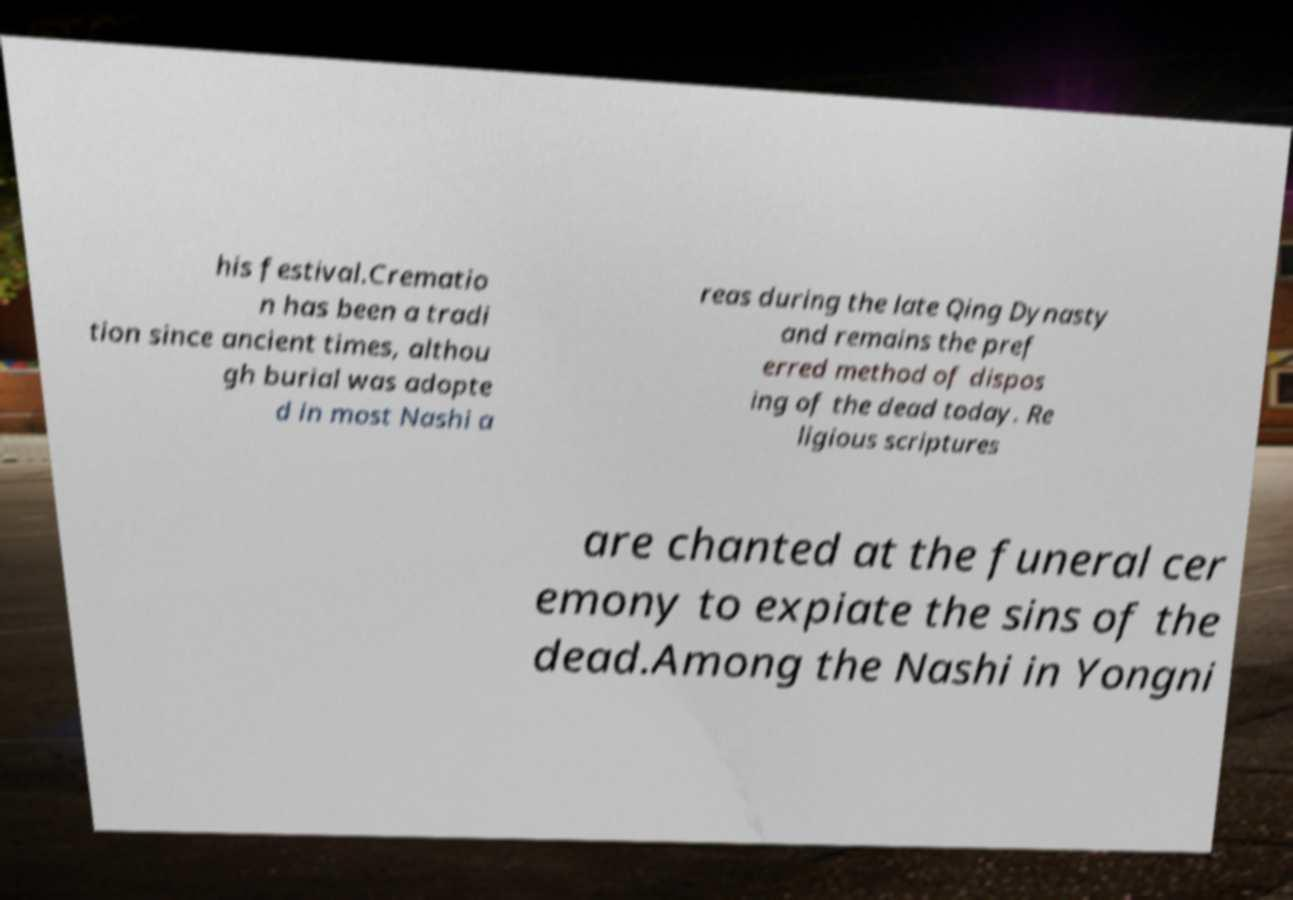Please identify and transcribe the text found in this image. his festival.Crematio n has been a tradi tion since ancient times, althou gh burial was adopte d in most Nashi a reas during the late Qing Dynasty and remains the pref erred method of dispos ing of the dead today. Re ligious scriptures are chanted at the funeral cer emony to expiate the sins of the dead.Among the Nashi in Yongni 